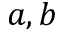Convert formula to latex. <formula><loc_0><loc_0><loc_500><loc_500>a , b</formula> 